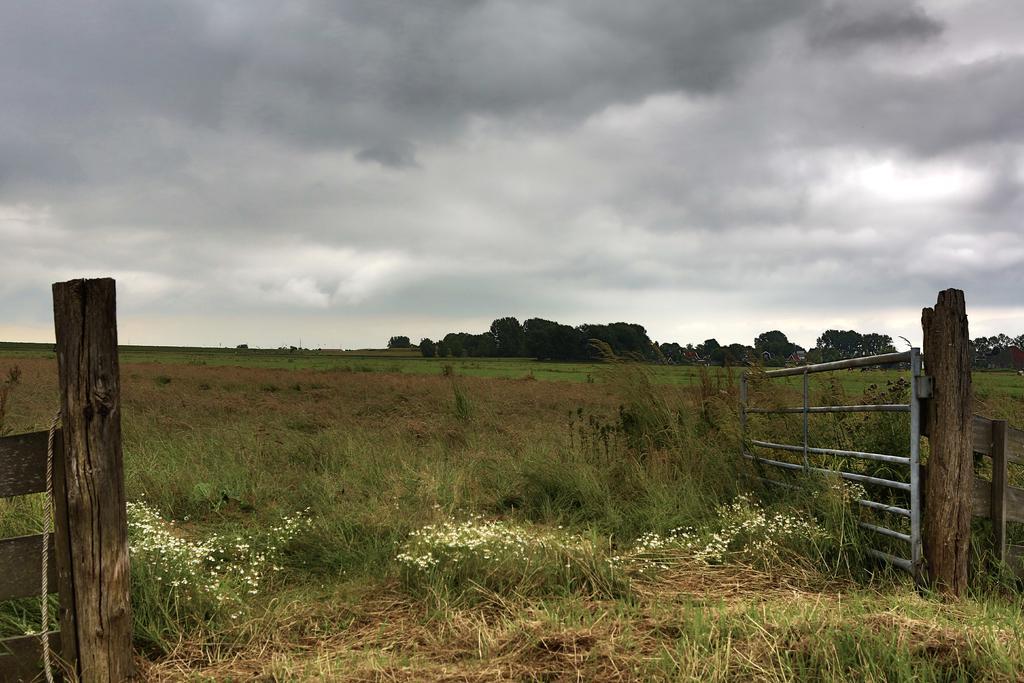Please provide a concise description of this image. In this image there are few plants having few flowers. Right side there is a fence attached to the wooden trunk. Background there are few trees on the grassland. Left bottom there is a fence. Top of the image there is sky with some clouds. 